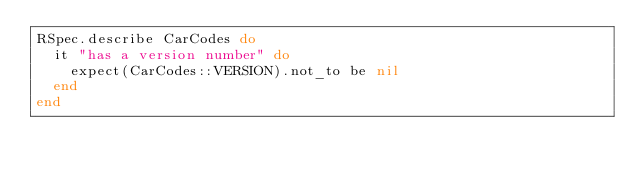Convert code to text. <code><loc_0><loc_0><loc_500><loc_500><_Ruby_>RSpec.describe CarCodes do
  it "has a version number" do
    expect(CarCodes::VERSION).not_to be nil
  end
end
</code> 